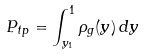Convert formula to latex. <formula><loc_0><loc_0><loc_500><loc_500>P _ { t p } = \int _ { y _ { 1 } } ^ { 1 } \rho _ { g } ( y ) \, d y</formula> 